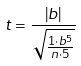<formula> <loc_0><loc_0><loc_500><loc_500>t = \frac { | b | } { \sqrt { \frac { 1 \cdot b ^ { 5 } } { n \cdot 5 } } }</formula> 